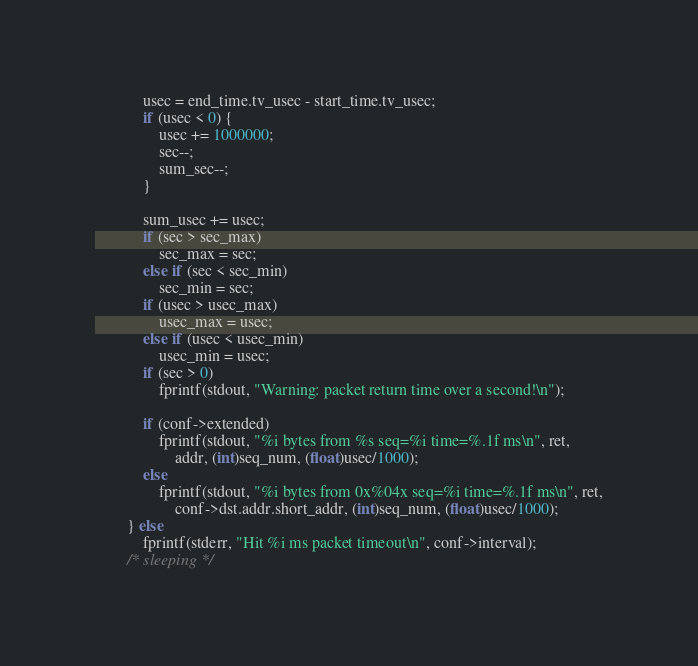<code> <loc_0><loc_0><loc_500><loc_500><_C_>			usec = end_time.tv_usec - start_time.tv_usec;
			if (usec < 0) {
				usec += 1000000;
				sec--;
				sum_sec--;
			}

			sum_usec += usec;
			if (sec > sec_max)
				sec_max = sec;
			else if (sec < sec_min)
				sec_min = sec;
			if (usec > usec_max)
				usec_max = usec;
			else if (usec < usec_min)
				usec_min = usec;
			if (sec > 0)
				fprintf(stdout, "Warning: packet return time over a second!\n");

			if (conf->extended)
				fprintf(stdout, "%i bytes from %s seq=%i time=%.1f ms\n", ret,
					addr, (int)seq_num, (float)usec/1000);
			else
				fprintf(stdout, "%i bytes from 0x%04x seq=%i time=%.1f ms\n", ret,
					conf->dst.addr.short_addr, (int)seq_num, (float)usec/1000);
		} else
			fprintf(stderr, "Hit %i ms packet timeout\n", conf->interval);
		/* sleeping */</code> 